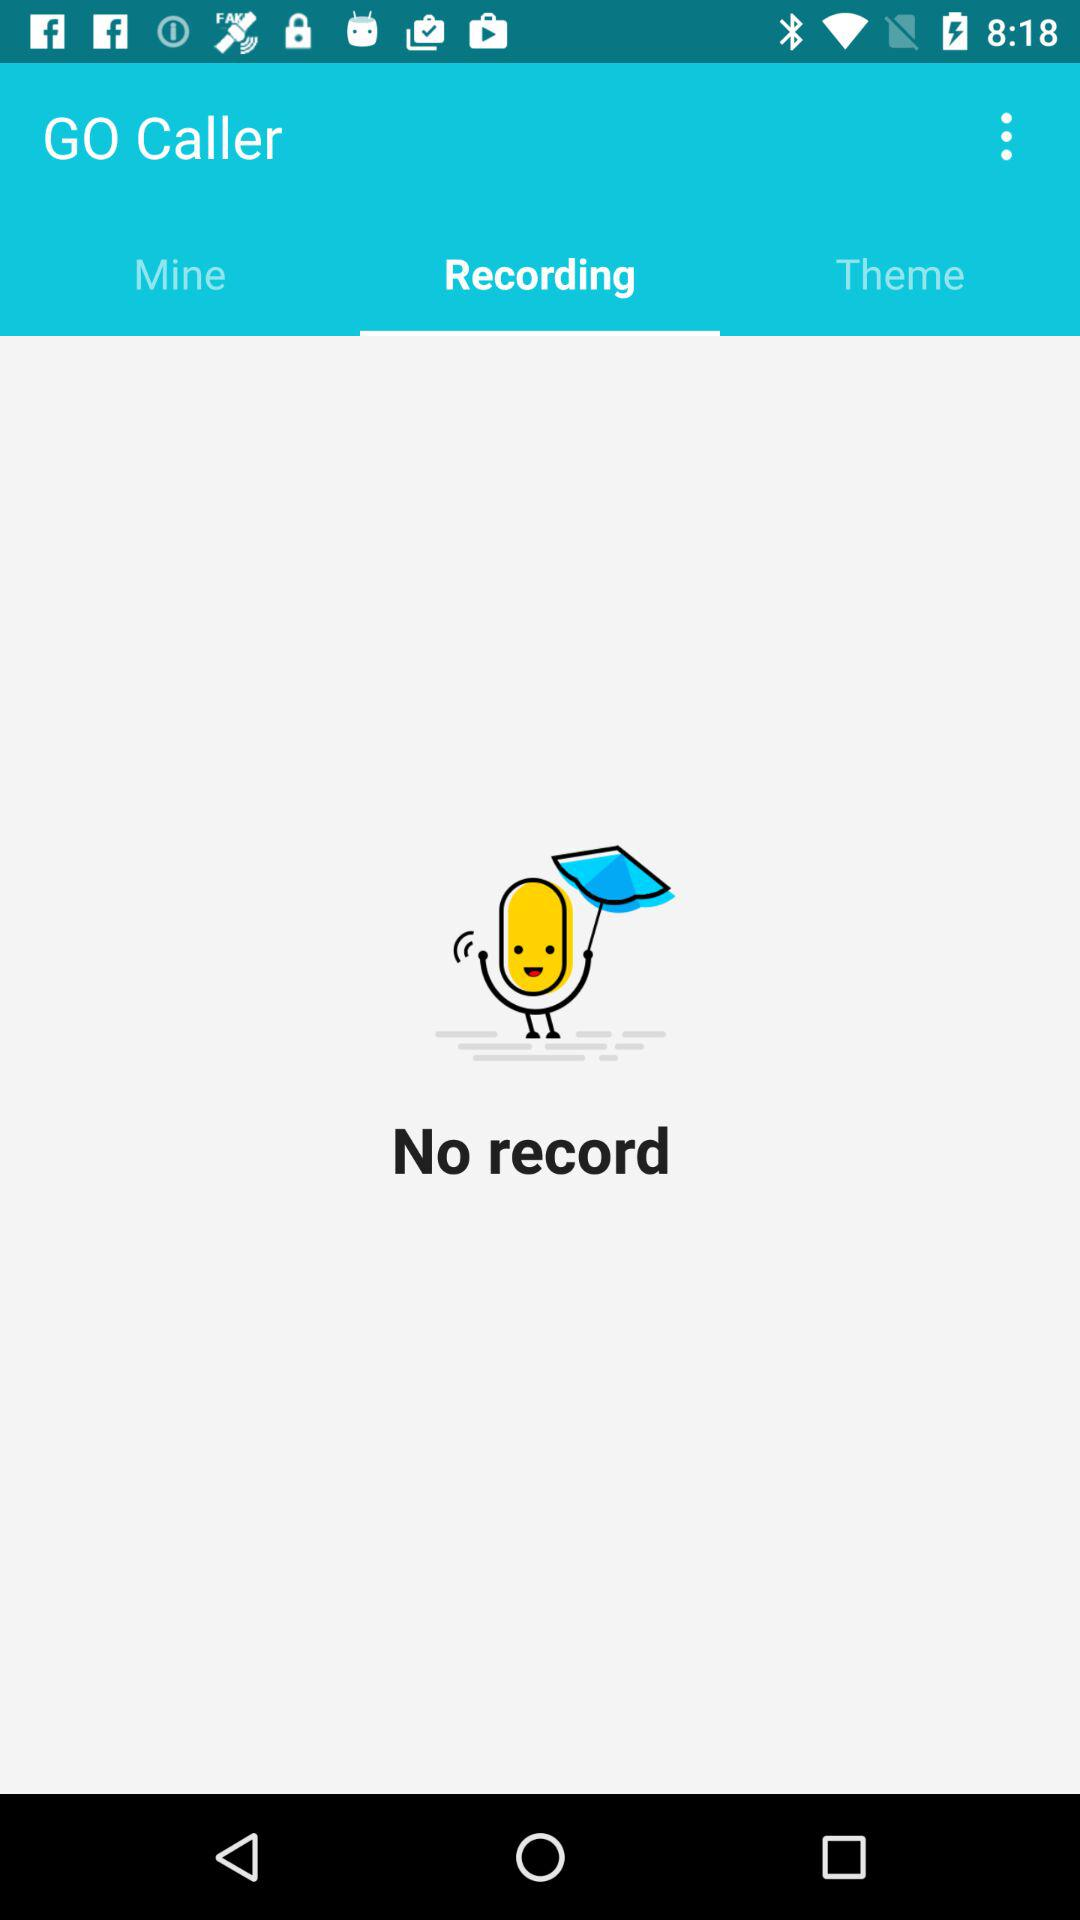What are the listed themes?
When the provided information is insufficient, respond with <no answer>. <no answer> 